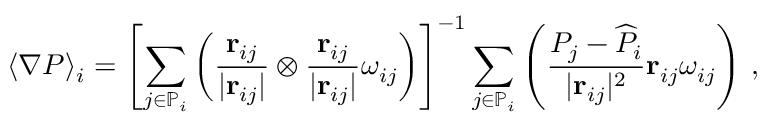<formula> <loc_0><loc_0><loc_500><loc_500>\langle \nabla P \rangle _ { i } = \left [ \sum _ { j \in \mathbb { P } _ { i } } \left ( \frac { r _ { i j } } { | r _ { i j } | } \otimes \frac { r _ { i j } } { | r _ { i j } | } \omega _ { i j } \right ) \right ] ^ { - 1 } \sum _ { j \in \mathbb { P } _ { i } } \left ( \frac { P _ { j } - \widehat { P } _ { i } } { | r _ { i j } | ^ { 2 } } r _ { i j } \omega _ { i j } \right ) \, ,</formula> 